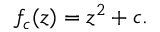Convert formula to latex. <formula><loc_0><loc_0><loc_500><loc_500>f _ { c } ( z ) = z ^ { 2 } + c .</formula> 